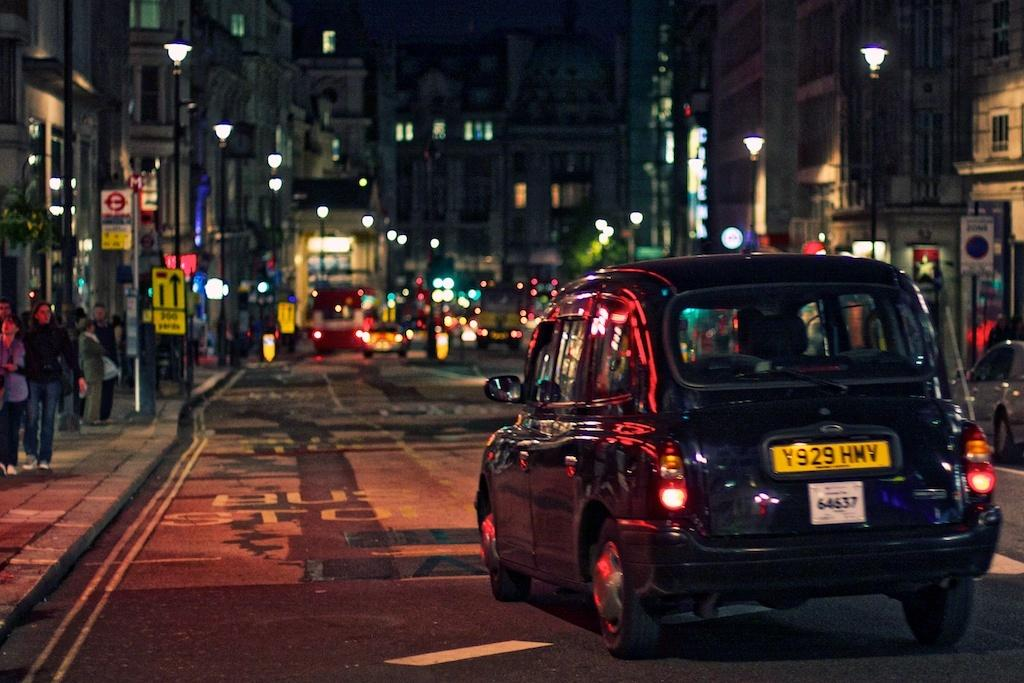What is the main subject in the front of the image? There is a car in the front of the image. What can be seen in the background of the image? There are buildings, poles, lights, vehicles, and boards in the background of the image. Are there any people visible in the image? Yes, there are people walking on the left side of the image. What type of bike is the mother riding in the image? There is no mother or bike present in the image. Can you describe the taste of the tongue in the image? There is no tongue present in the image. 